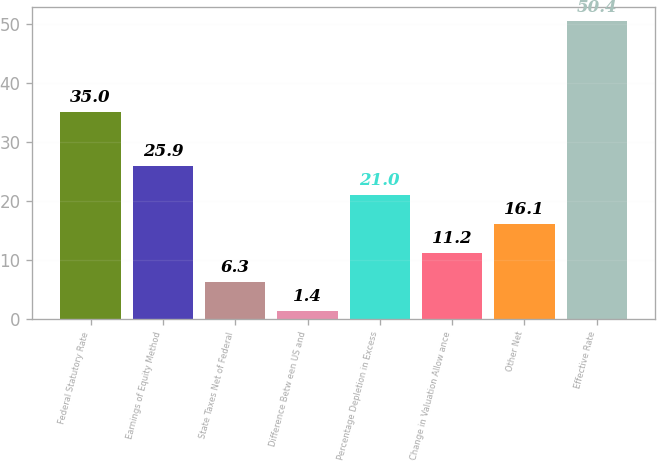Convert chart. <chart><loc_0><loc_0><loc_500><loc_500><bar_chart><fcel>Federal Statutory Rate<fcel>Earnings of Equity Method<fcel>State Taxes Net of Federal<fcel>Difference Betw een US and<fcel>Percentage Depletion in Excess<fcel>Change in Valuation Allow ance<fcel>Other Net<fcel>Effective Rate<nl><fcel>35<fcel>25.9<fcel>6.3<fcel>1.4<fcel>21<fcel>11.2<fcel>16.1<fcel>50.4<nl></chart> 